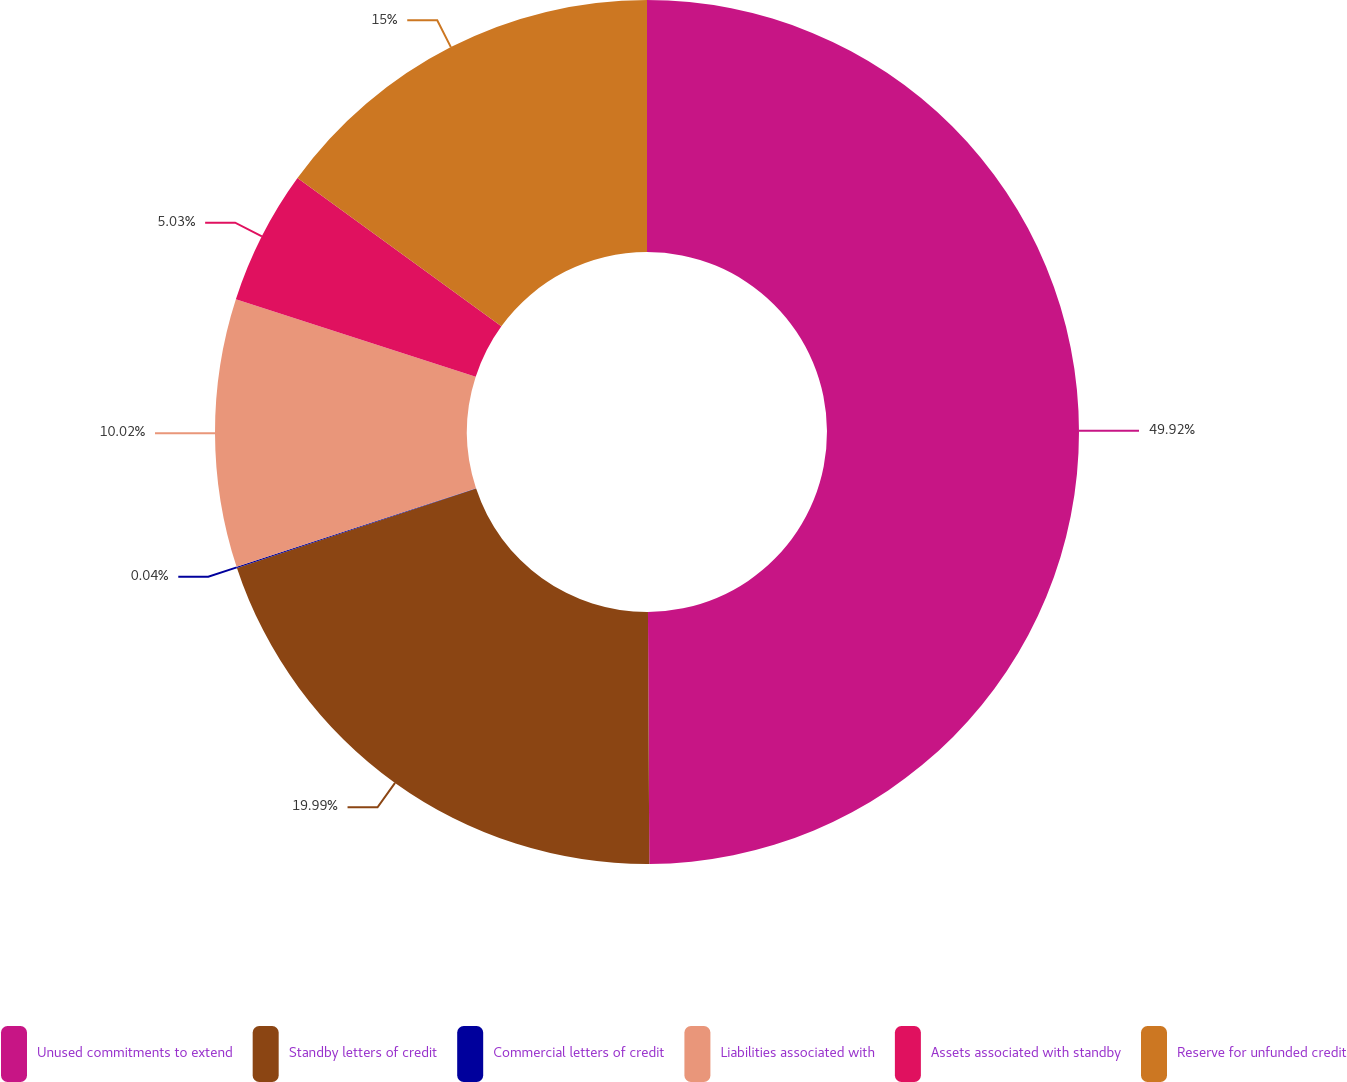<chart> <loc_0><loc_0><loc_500><loc_500><pie_chart><fcel>Unused commitments to extend<fcel>Standby letters of credit<fcel>Commercial letters of credit<fcel>Liabilities associated with<fcel>Assets associated with standby<fcel>Reserve for unfunded credit<nl><fcel>49.91%<fcel>19.99%<fcel>0.04%<fcel>10.02%<fcel>5.03%<fcel>15.0%<nl></chart> 